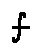<formula> <loc_0><loc_0><loc_500><loc_500>f</formula> 